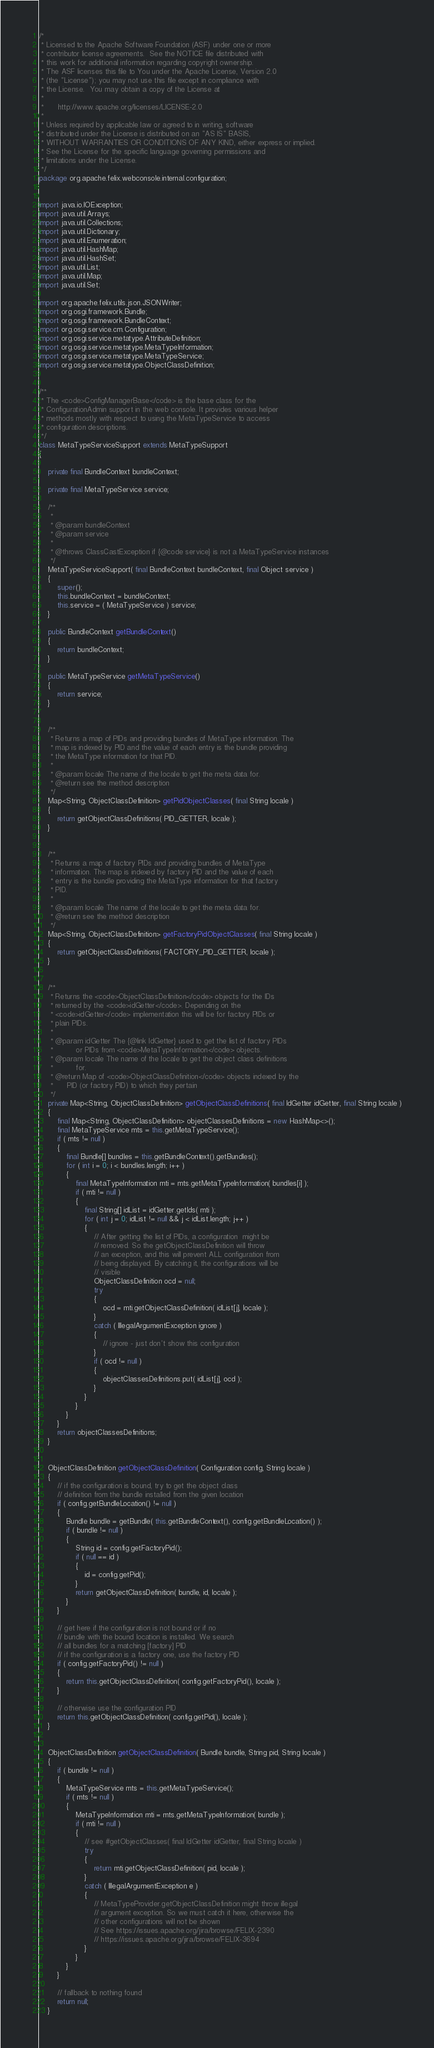Convert code to text. <code><loc_0><loc_0><loc_500><loc_500><_Java_>/*
 * Licensed to the Apache Software Foundation (ASF) under one or more
 * contributor license agreements.  See the NOTICE file distributed with
 * this work for additional information regarding copyright ownership.
 * The ASF licenses this file to You under the Apache License, Version 2.0
 * (the "License"); you may not use this file except in compliance with
 * the License.  You may obtain a copy of the License at
 *
 *      http://www.apache.org/licenses/LICENSE-2.0
 *
 * Unless required by applicable law or agreed to in writing, software
 * distributed under the License is distributed on an "AS IS" BASIS,
 * WITHOUT WARRANTIES OR CONDITIONS OF ANY KIND, either express or implied.
 * See the License for the specific language governing permissions and
 * limitations under the License.
 */
package org.apache.felix.webconsole.internal.configuration;


import java.io.IOException;
import java.util.Arrays;
import java.util.Collections;
import java.util.Dictionary;
import java.util.Enumeration;
import java.util.HashMap;
import java.util.HashSet;
import java.util.List;
import java.util.Map;
import java.util.Set;

import org.apache.felix.utils.json.JSONWriter;
import org.osgi.framework.Bundle;
import org.osgi.framework.BundleContext;
import org.osgi.service.cm.Configuration;
import org.osgi.service.metatype.AttributeDefinition;
import org.osgi.service.metatype.MetaTypeInformation;
import org.osgi.service.metatype.MetaTypeService;
import org.osgi.service.metatype.ObjectClassDefinition;


/**
 * The <code>ConfigManagerBase</code> is the base class for the
 * ConfigurationAdmin support in the web console. It provides various helper
 * methods mostly with respect to using the MetaTypeService to access
 * configuration descriptions.
 */
class MetaTypeServiceSupport extends MetaTypeSupport
{

    private final BundleContext bundleContext;

    private final MetaTypeService service;

    /**
     *
     * @param bundleContext
     * @param service
     *
     * @throws ClassCastException if {@code service} is not a MetaTypeService instances
     */
    MetaTypeServiceSupport( final BundleContext bundleContext, final Object service )
    {
        super();
        this.bundleContext = bundleContext;
        this.service = ( MetaTypeService ) service;
    }

    public BundleContext getBundleContext()
    {
        return bundleContext;
    }

    public MetaTypeService getMetaTypeService()
    {
        return service;
    }


    /**
     * Returns a map of PIDs and providing bundles of MetaType information. The
     * map is indexed by PID and the value of each entry is the bundle providing
     * the MetaType information for that PID.
     *
     * @param locale The name of the locale to get the meta data for.
     * @return see the method description
     */
    Map<String, ObjectClassDefinition> getPidObjectClasses( final String locale )
    {
        return getObjectClassDefinitions( PID_GETTER, locale );
    }


    /**
     * Returns a map of factory PIDs and providing bundles of MetaType
     * information. The map is indexed by factory PID and the value of each
     * entry is the bundle providing the MetaType information for that factory
     * PID.
     *
     * @param locale The name of the locale to get the meta data for.
     * @return see the method description
     */
    Map<String, ObjectClassDefinition> getFactoryPidObjectClasses( final String locale )
    {
        return getObjectClassDefinitions( FACTORY_PID_GETTER, locale );
    }


    /**
     * Returns the <code>ObjectClassDefinition</code> objects for the IDs
     * returned by the <code>idGetter</code>. Depending on the
     * <code>idGetter</code> implementation this will be for factory PIDs or
     * plain PIDs.
     *
     * @param idGetter The {@link IdGetter} used to get the list of factory PIDs
     *          or PIDs from <code>MetaTypeInformation</code> objects.
     * @param locale The name of the locale to get the object class definitions
     *          for.
     * @return Map of <code>ObjectClassDefinition</code> objects indexed by the
     *      PID (or factory PID) to which they pertain
     */
    private Map<String, ObjectClassDefinition> getObjectClassDefinitions( final IdGetter idGetter, final String locale )
    {
        final Map<String, ObjectClassDefinition> objectClassesDefinitions = new HashMap<>();
        final MetaTypeService mts = this.getMetaTypeService();
        if ( mts != null )
        {
            final Bundle[] bundles = this.getBundleContext().getBundles();
            for ( int i = 0; i < bundles.length; i++ )
            {
                final MetaTypeInformation mti = mts.getMetaTypeInformation( bundles[i] );
                if ( mti != null )
                {
                    final String[] idList = idGetter.getIds( mti );
                    for ( int j = 0; idList != null && j < idList.length; j++ )
                    {
                        // After getting the list of PIDs, a configuration  might be
                        // removed. So the getObjectClassDefinition will throw
                        // an exception, and this will prevent ALL configuration from
                        // being displayed. By catching it, the configurations will be
                        // visible
                        ObjectClassDefinition ocd = null;
                        try
                        {
                            ocd = mti.getObjectClassDefinition( idList[j], locale );
                        }
                        catch ( IllegalArgumentException ignore )
                        {
                            // ignore - just don't show this configuration
                        }
                        if ( ocd != null )
                        {
                            objectClassesDefinitions.put( idList[j], ocd );
                        }
                    }
                }
            }
        }
        return objectClassesDefinitions;
    }


    ObjectClassDefinition getObjectClassDefinition( Configuration config, String locale )
    {
        // if the configuration is bound, try to get the object class
        // definition from the bundle installed from the given location
        if ( config.getBundleLocation() != null )
        {
            Bundle bundle = getBundle( this.getBundleContext(), config.getBundleLocation() );
            if ( bundle != null )
            {
                String id = config.getFactoryPid();
                if ( null == id )
                {
                    id = config.getPid();
                }
                return getObjectClassDefinition( bundle, id, locale );
            }
        }

        // get here if the configuration is not bound or if no
        // bundle with the bound location is installed. We search
        // all bundles for a matching [factory] PID
        // if the configuration is a factory one, use the factory PID
        if ( config.getFactoryPid() != null )
        {
            return this.getObjectClassDefinition( config.getFactoryPid(), locale );
        }

        // otherwise use the configuration PID
        return this.getObjectClassDefinition( config.getPid(), locale );
    }


    ObjectClassDefinition getObjectClassDefinition( Bundle bundle, String pid, String locale )
    {
        if ( bundle != null )
        {
            MetaTypeService mts = this.getMetaTypeService();
            if ( mts != null )
            {
                MetaTypeInformation mti = mts.getMetaTypeInformation( bundle );
                if ( mti != null )
                {
                    // see #getObjectClasses( final IdGetter idGetter, final String locale )
                    try
                    {
                        return mti.getObjectClassDefinition( pid, locale );
                    }
                    catch ( IllegalArgumentException e )
                    {
                        // MetaTypeProvider.getObjectClassDefinition might throw illegal
                        // argument exception. So we must catch it here, otherwise the
                        // other configurations will not be shown
                        // See https://issues.apache.org/jira/browse/FELIX-2390
                        // https://issues.apache.org/jira/browse/FELIX-3694
                    }
                }
            }
        }

        // fallback to nothing found
        return null;
    }

</code> 